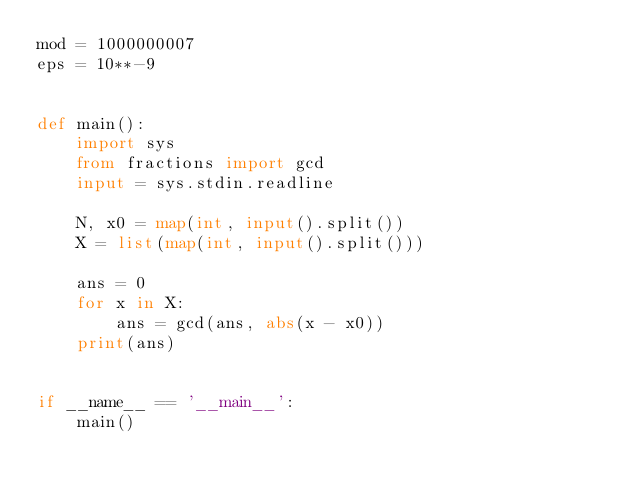<code> <loc_0><loc_0><loc_500><loc_500><_Python_>mod = 1000000007
eps = 10**-9


def main():
    import sys
    from fractions import gcd
    input = sys.stdin.readline

    N, x0 = map(int, input().split())
    X = list(map(int, input().split()))

    ans = 0
    for x in X:
        ans = gcd(ans, abs(x - x0))
    print(ans)


if __name__ == '__main__':
    main()
</code> 